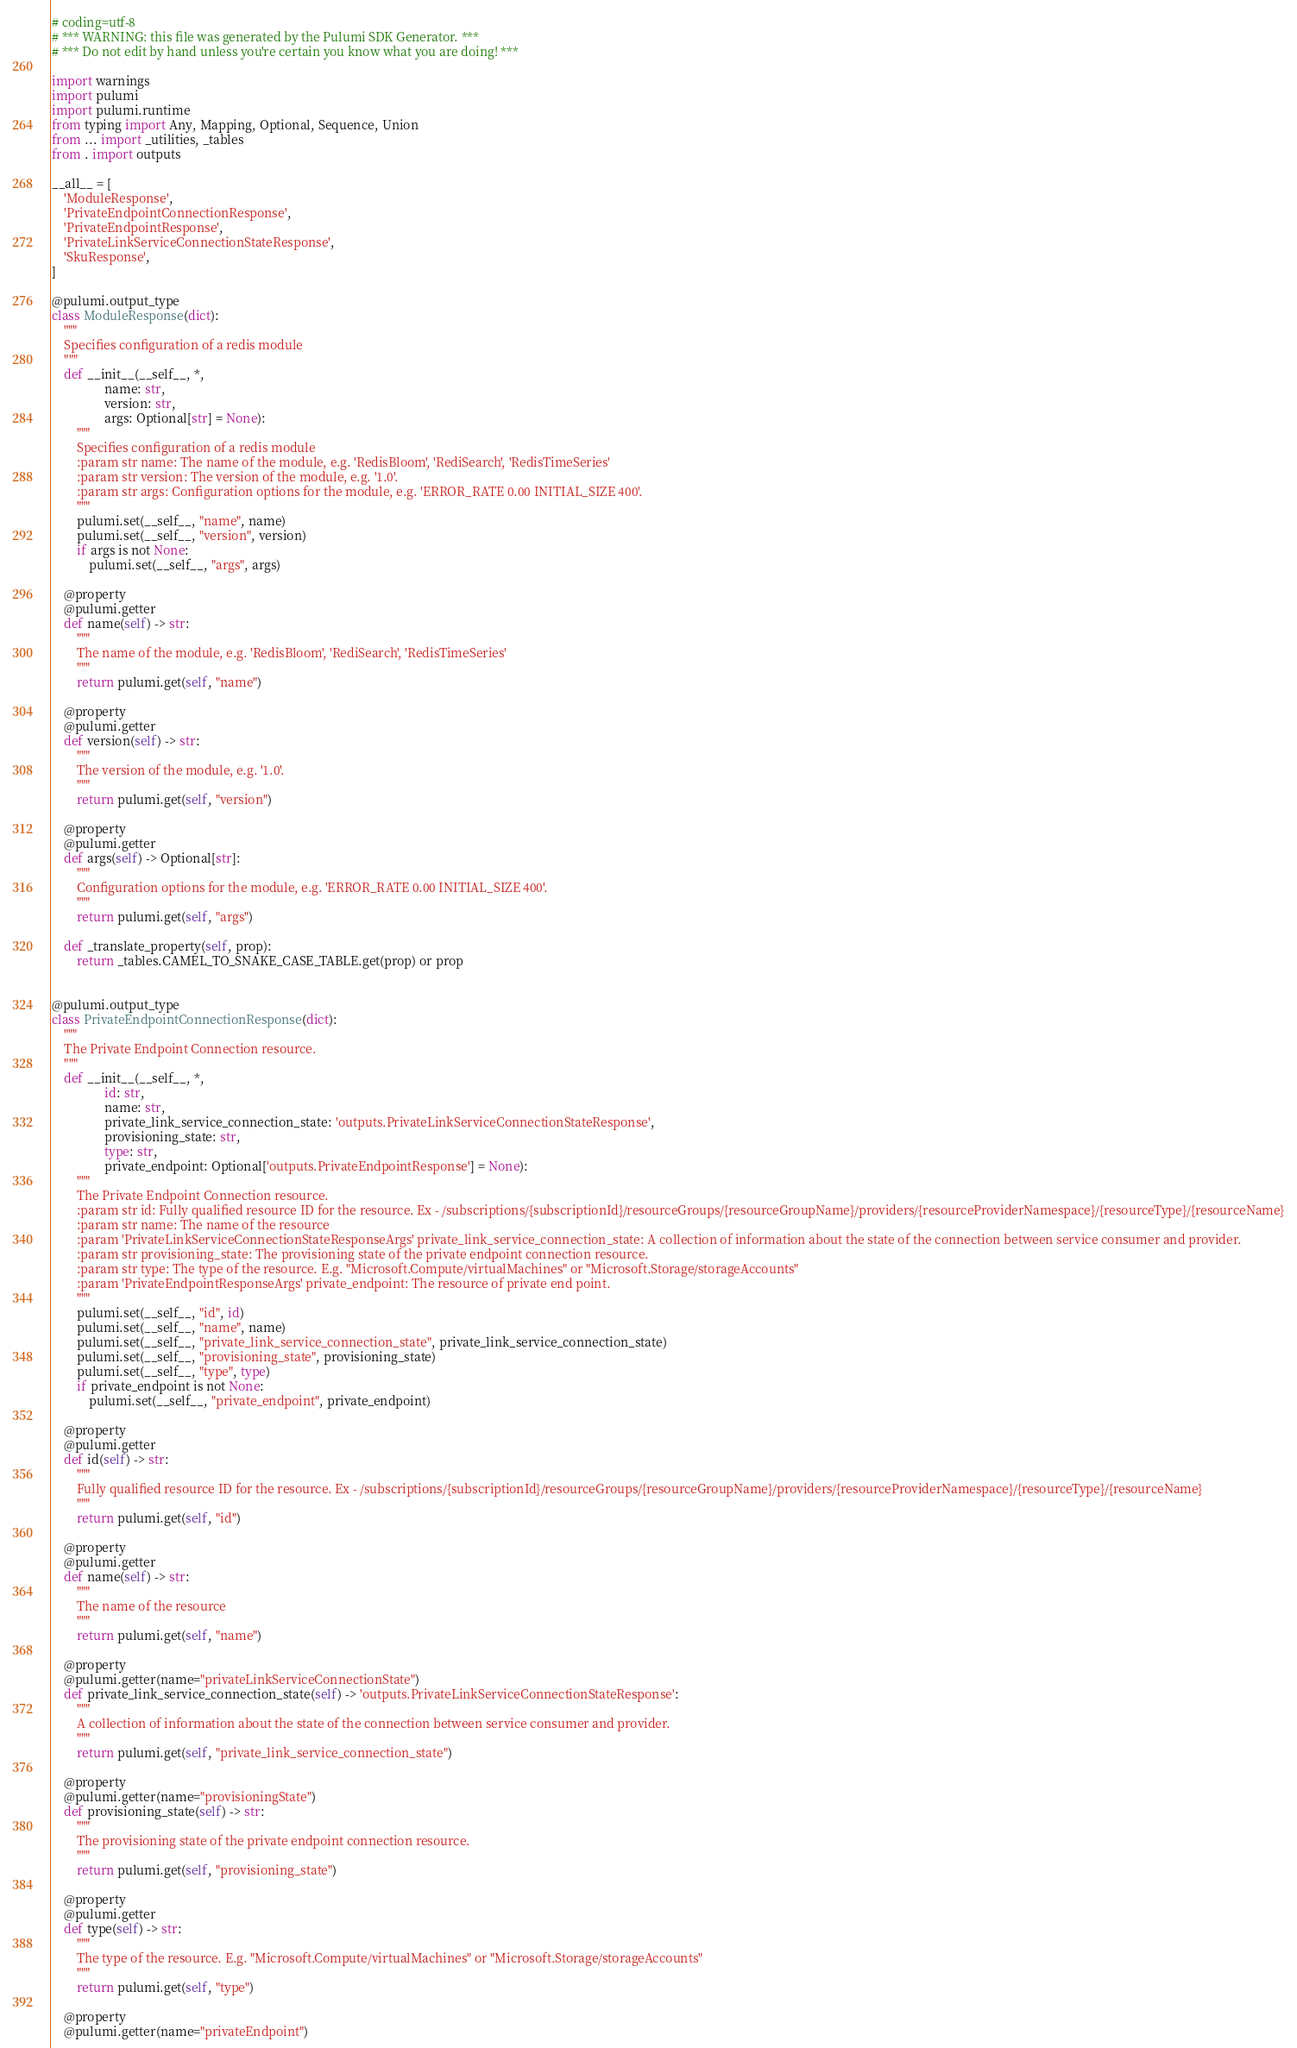Convert code to text. <code><loc_0><loc_0><loc_500><loc_500><_Python_># coding=utf-8
# *** WARNING: this file was generated by the Pulumi SDK Generator. ***
# *** Do not edit by hand unless you're certain you know what you are doing! ***

import warnings
import pulumi
import pulumi.runtime
from typing import Any, Mapping, Optional, Sequence, Union
from ... import _utilities, _tables
from . import outputs

__all__ = [
    'ModuleResponse',
    'PrivateEndpointConnectionResponse',
    'PrivateEndpointResponse',
    'PrivateLinkServiceConnectionStateResponse',
    'SkuResponse',
]

@pulumi.output_type
class ModuleResponse(dict):
    """
    Specifies configuration of a redis module
    """
    def __init__(__self__, *,
                 name: str,
                 version: str,
                 args: Optional[str] = None):
        """
        Specifies configuration of a redis module
        :param str name: The name of the module, e.g. 'RedisBloom', 'RediSearch', 'RedisTimeSeries'
        :param str version: The version of the module, e.g. '1.0'.
        :param str args: Configuration options for the module, e.g. 'ERROR_RATE 0.00 INITIAL_SIZE 400'.
        """
        pulumi.set(__self__, "name", name)
        pulumi.set(__self__, "version", version)
        if args is not None:
            pulumi.set(__self__, "args", args)

    @property
    @pulumi.getter
    def name(self) -> str:
        """
        The name of the module, e.g. 'RedisBloom', 'RediSearch', 'RedisTimeSeries'
        """
        return pulumi.get(self, "name")

    @property
    @pulumi.getter
    def version(self) -> str:
        """
        The version of the module, e.g. '1.0'.
        """
        return pulumi.get(self, "version")

    @property
    @pulumi.getter
    def args(self) -> Optional[str]:
        """
        Configuration options for the module, e.g. 'ERROR_RATE 0.00 INITIAL_SIZE 400'.
        """
        return pulumi.get(self, "args")

    def _translate_property(self, prop):
        return _tables.CAMEL_TO_SNAKE_CASE_TABLE.get(prop) or prop


@pulumi.output_type
class PrivateEndpointConnectionResponse(dict):
    """
    The Private Endpoint Connection resource.
    """
    def __init__(__self__, *,
                 id: str,
                 name: str,
                 private_link_service_connection_state: 'outputs.PrivateLinkServiceConnectionStateResponse',
                 provisioning_state: str,
                 type: str,
                 private_endpoint: Optional['outputs.PrivateEndpointResponse'] = None):
        """
        The Private Endpoint Connection resource.
        :param str id: Fully qualified resource ID for the resource. Ex - /subscriptions/{subscriptionId}/resourceGroups/{resourceGroupName}/providers/{resourceProviderNamespace}/{resourceType}/{resourceName}
        :param str name: The name of the resource
        :param 'PrivateLinkServiceConnectionStateResponseArgs' private_link_service_connection_state: A collection of information about the state of the connection between service consumer and provider.
        :param str provisioning_state: The provisioning state of the private endpoint connection resource.
        :param str type: The type of the resource. E.g. "Microsoft.Compute/virtualMachines" or "Microsoft.Storage/storageAccounts"
        :param 'PrivateEndpointResponseArgs' private_endpoint: The resource of private end point.
        """
        pulumi.set(__self__, "id", id)
        pulumi.set(__self__, "name", name)
        pulumi.set(__self__, "private_link_service_connection_state", private_link_service_connection_state)
        pulumi.set(__self__, "provisioning_state", provisioning_state)
        pulumi.set(__self__, "type", type)
        if private_endpoint is not None:
            pulumi.set(__self__, "private_endpoint", private_endpoint)

    @property
    @pulumi.getter
    def id(self) -> str:
        """
        Fully qualified resource ID for the resource. Ex - /subscriptions/{subscriptionId}/resourceGroups/{resourceGroupName}/providers/{resourceProviderNamespace}/{resourceType}/{resourceName}
        """
        return pulumi.get(self, "id")

    @property
    @pulumi.getter
    def name(self) -> str:
        """
        The name of the resource
        """
        return pulumi.get(self, "name")

    @property
    @pulumi.getter(name="privateLinkServiceConnectionState")
    def private_link_service_connection_state(self) -> 'outputs.PrivateLinkServiceConnectionStateResponse':
        """
        A collection of information about the state of the connection between service consumer and provider.
        """
        return pulumi.get(self, "private_link_service_connection_state")

    @property
    @pulumi.getter(name="provisioningState")
    def provisioning_state(self) -> str:
        """
        The provisioning state of the private endpoint connection resource.
        """
        return pulumi.get(self, "provisioning_state")

    @property
    @pulumi.getter
    def type(self) -> str:
        """
        The type of the resource. E.g. "Microsoft.Compute/virtualMachines" or "Microsoft.Storage/storageAccounts"
        """
        return pulumi.get(self, "type")

    @property
    @pulumi.getter(name="privateEndpoint")</code> 